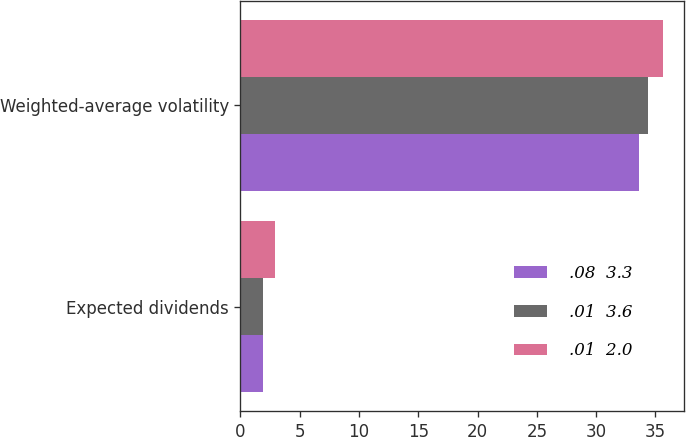Convert chart to OTSL. <chart><loc_0><loc_0><loc_500><loc_500><stacked_bar_chart><ecel><fcel>Expected dividends<fcel>Weighted-average volatility<nl><fcel>.08  3.3<fcel>1.9<fcel>33.6<nl><fcel>.01  3.6<fcel>1.9<fcel>34.4<nl><fcel>.01  2.0<fcel>2.9<fcel>35.6<nl></chart> 